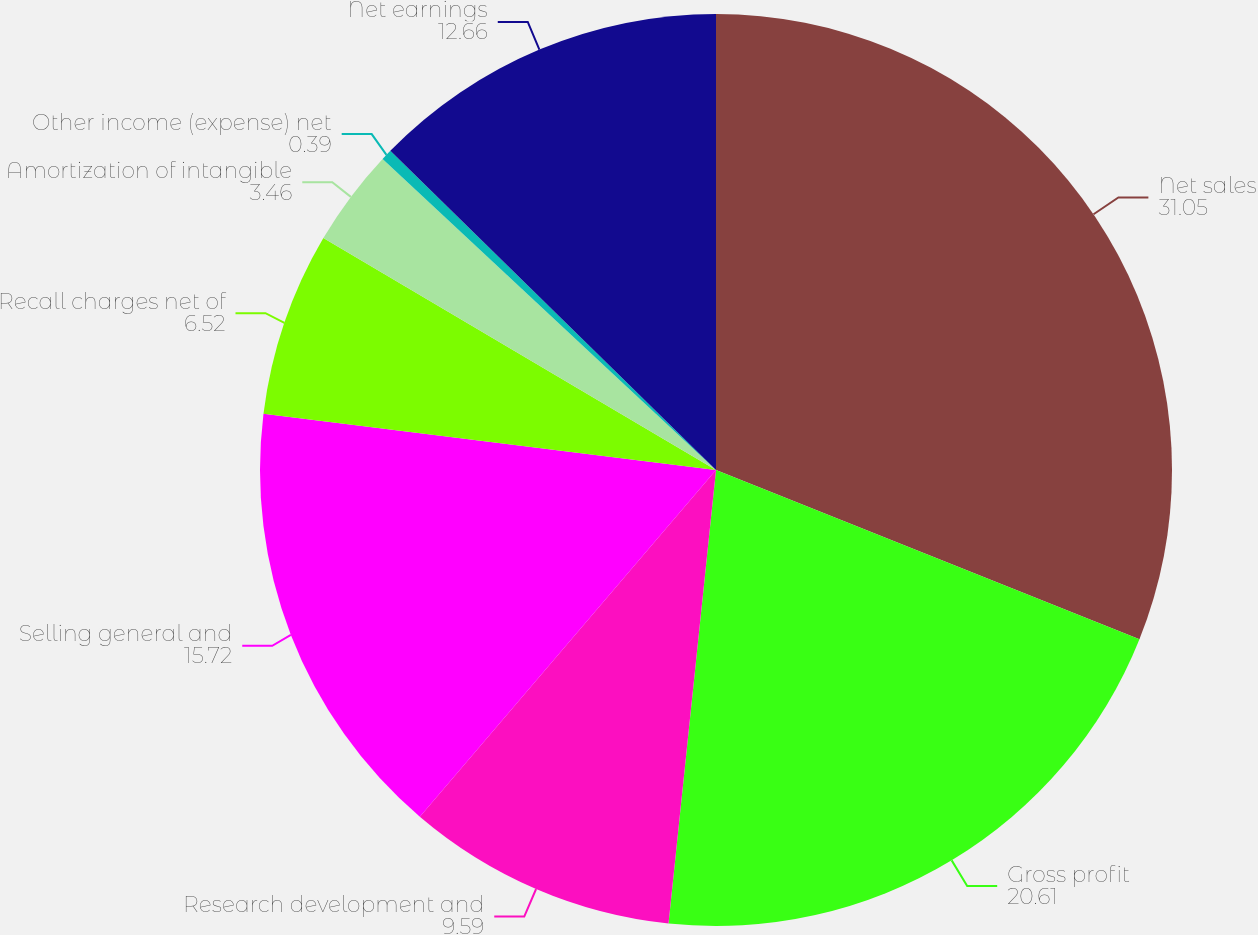Convert chart. <chart><loc_0><loc_0><loc_500><loc_500><pie_chart><fcel>Net sales<fcel>Gross profit<fcel>Research development and<fcel>Selling general and<fcel>Recall charges net of<fcel>Amortization of intangible<fcel>Other income (expense) net<fcel>Net earnings<nl><fcel>31.05%<fcel>20.61%<fcel>9.59%<fcel>15.72%<fcel>6.52%<fcel>3.46%<fcel>0.39%<fcel>12.66%<nl></chart> 